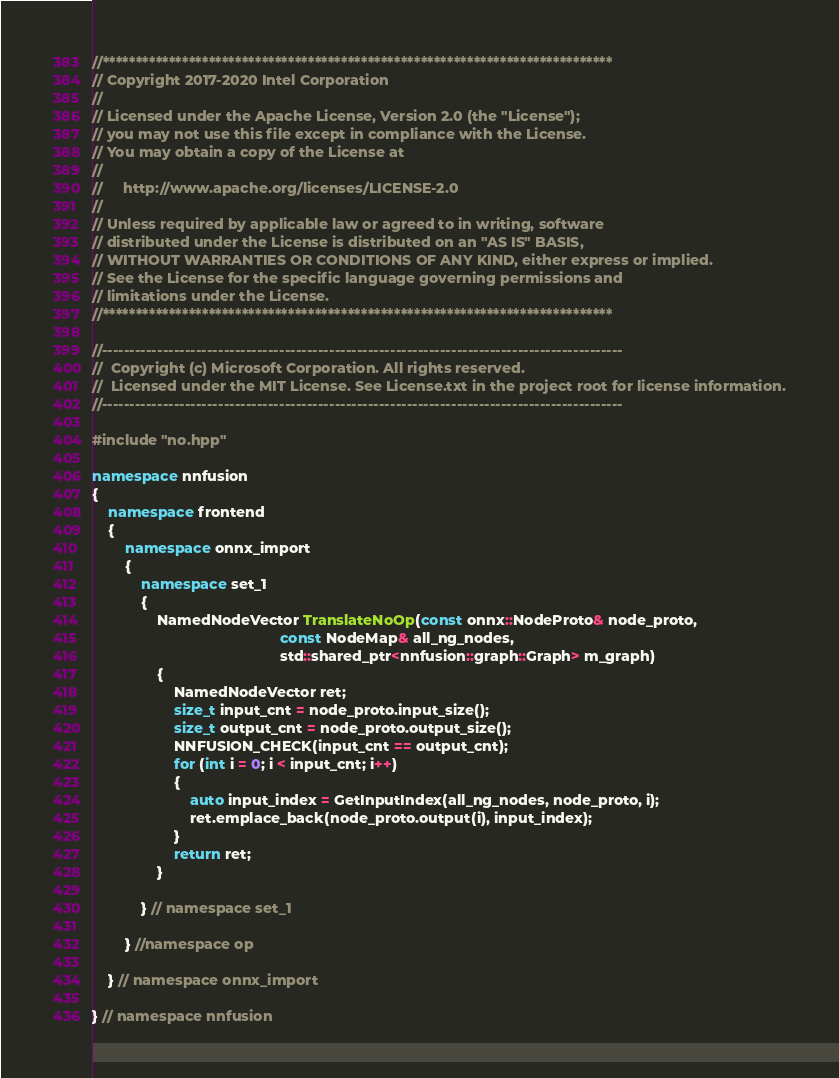Convert code to text. <code><loc_0><loc_0><loc_500><loc_500><_C++_>//*****************************************************************************
// Copyright 2017-2020 Intel Corporation
//
// Licensed under the Apache License, Version 2.0 (the "License");
// you may not use this file except in compliance with the License.
// You may obtain a copy of the License at
//
//     http://www.apache.org/licenses/LICENSE-2.0
//
// Unless required by applicable law or agreed to in writing, software
// distributed under the License is distributed on an "AS IS" BASIS,
// WITHOUT WARRANTIES OR CONDITIONS OF ANY KIND, either express or implied.
// See the License for the specific language governing permissions and
// limitations under the License.
//*****************************************************************************

//----------------------------------------------------------------------------------------------
//  Copyright (c) Microsoft Corporation. All rights reserved.
//  Licensed under the MIT License. See License.txt in the project root for license information.
//----------------------------------------------------------------------------------------------

#include "no.hpp"

namespace nnfusion
{
    namespace frontend
    {
        namespace onnx_import
        {
            namespace set_1
            {
                NamedNodeVector TranslateNoOp(const onnx::NodeProto& node_proto,
                                              const NodeMap& all_ng_nodes,
                                              std::shared_ptr<nnfusion::graph::Graph> m_graph)
                {
                    NamedNodeVector ret;
                    size_t input_cnt = node_proto.input_size();
                    size_t output_cnt = node_proto.output_size();
                    NNFUSION_CHECK(input_cnt == output_cnt);
                    for (int i = 0; i < input_cnt; i++)
                    {
                        auto input_index = GetInputIndex(all_ng_nodes, node_proto, i);
                        ret.emplace_back(node_proto.output(i), input_index);
                    }
                    return ret;
                }

            } // namespace set_1

        } //namespace op

    } // namespace onnx_import

} // namespace nnfusion
</code> 